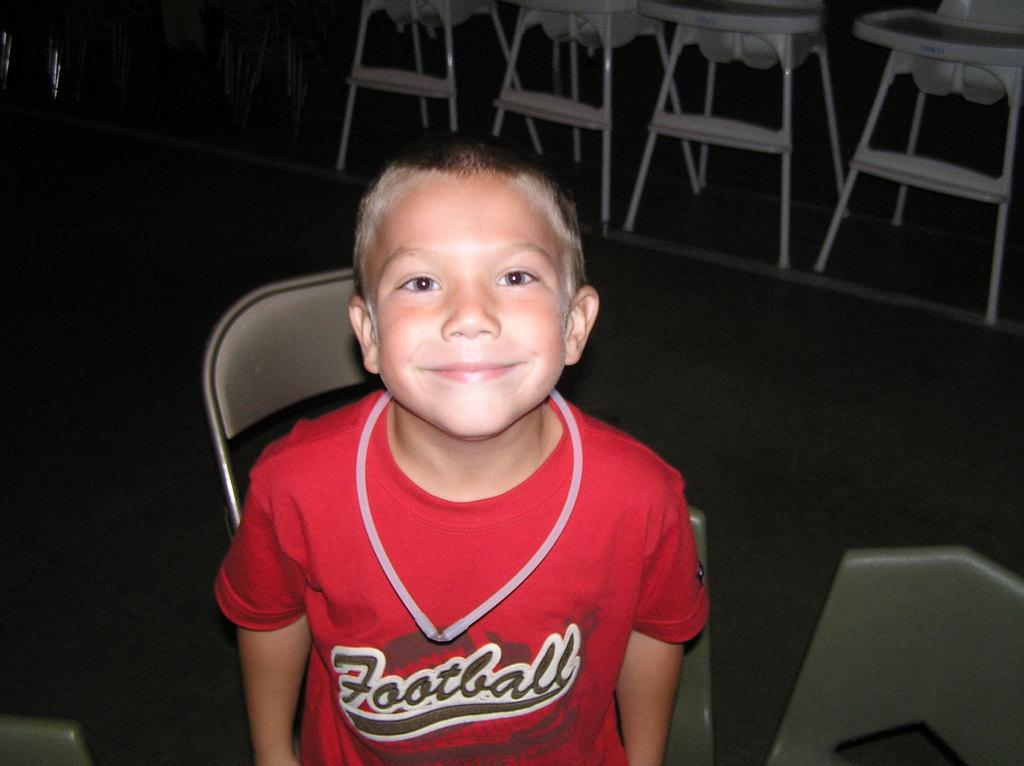<image>
Summarize the visual content of the image. A kid is wearing a red shirt with the word football on it. 